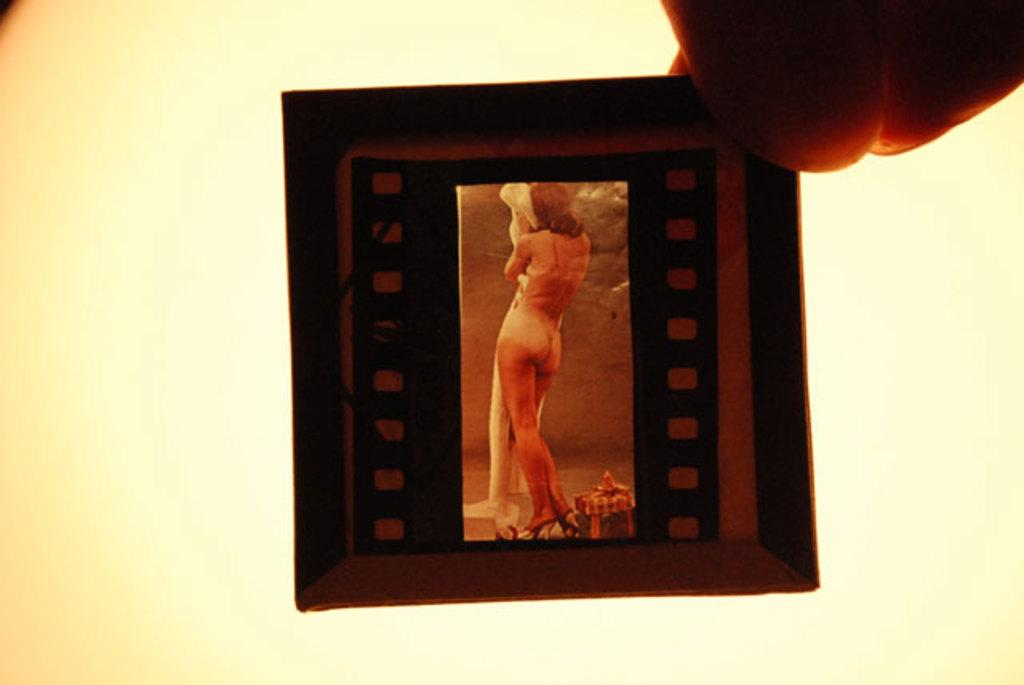What is the person in the image holding? The person in the image is holding a photo reel. What can be seen in the photo reel? The photo reel contains an image of a lady. What is the lady in the image holding? The lady in the image is holding a cloth. Are there any other objects visible in the image of the lady? Yes, there are other objects in the image of the lady. What is visible in the background of the image? There is a wall in the background of the image. Can you tell me how many dogs are visible in the image? There are no dogs present in the image. What type of farm can be seen in the background of the image? There is no farm visible in the image; only a wall is present in the background. 